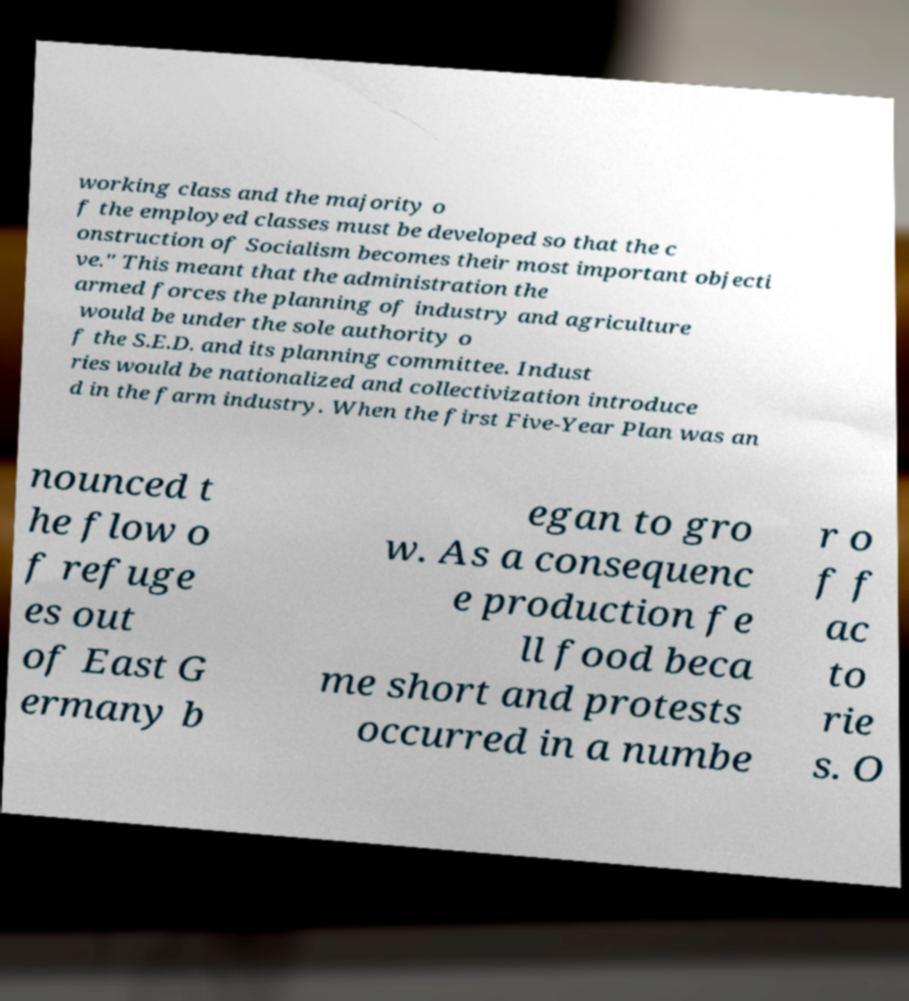Could you extract and type out the text from this image? working class and the majority o f the employed classes must be developed so that the c onstruction of Socialism becomes their most important objecti ve." This meant that the administration the armed forces the planning of industry and agriculture would be under the sole authority o f the S.E.D. and its planning committee. Indust ries would be nationalized and collectivization introduce d in the farm industry. When the first Five-Year Plan was an nounced t he flow o f refuge es out of East G ermany b egan to gro w. As a consequenc e production fe ll food beca me short and protests occurred in a numbe r o f f ac to rie s. O 